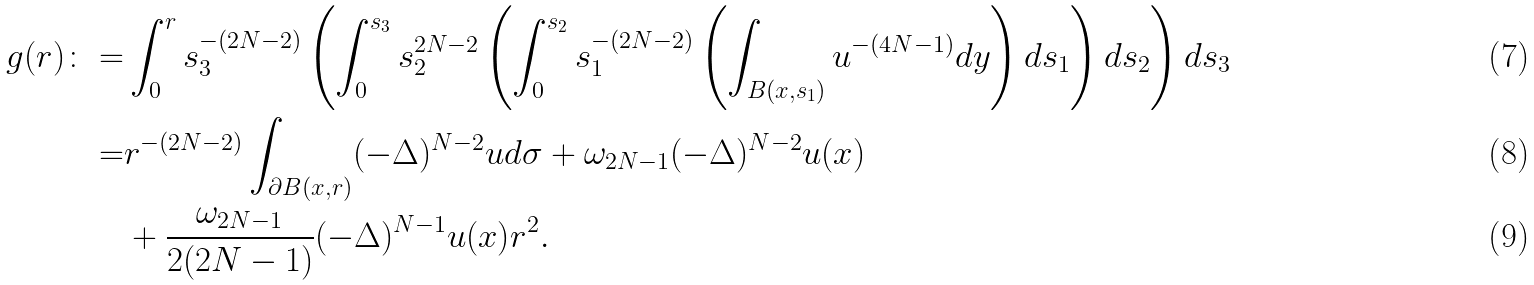Convert formula to latex. <formula><loc_0><loc_0><loc_500><loc_500>g ( r ) \colon = & \int _ { 0 } ^ { r } s _ { 3 } ^ { - ( 2 N - 2 ) } \left ( \int _ { 0 } ^ { s _ { 3 } } s _ { 2 } ^ { 2 N - 2 } \left ( \int _ { 0 } ^ { s _ { 2 } } s _ { 1 } ^ { - ( 2 N - 2 ) } \left ( \int _ { B ( x , s _ { 1 } ) } u ^ { - ( 4 N - 1 ) } d y \right ) d s _ { 1 } \right ) d s _ { 2 } \right ) d s _ { 3 } \\ = & r ^ { - ( 2 N - 2 ) } \int _ { \partial B ( x , r ) } ( - \Delta ) ^ { N - 2 } u d \sigma + \omega _ { 2 N - 1 } ( - \Delta ) ^ { N - 2 } u ( x ) \\ & + \frac { \omega _ { 2 N - 1 } } { 2 ( 2 N - 1 ) } ( - \Delta ) ^ { N - 1 } u ( x ) r ^ { 2 } .</formula> 